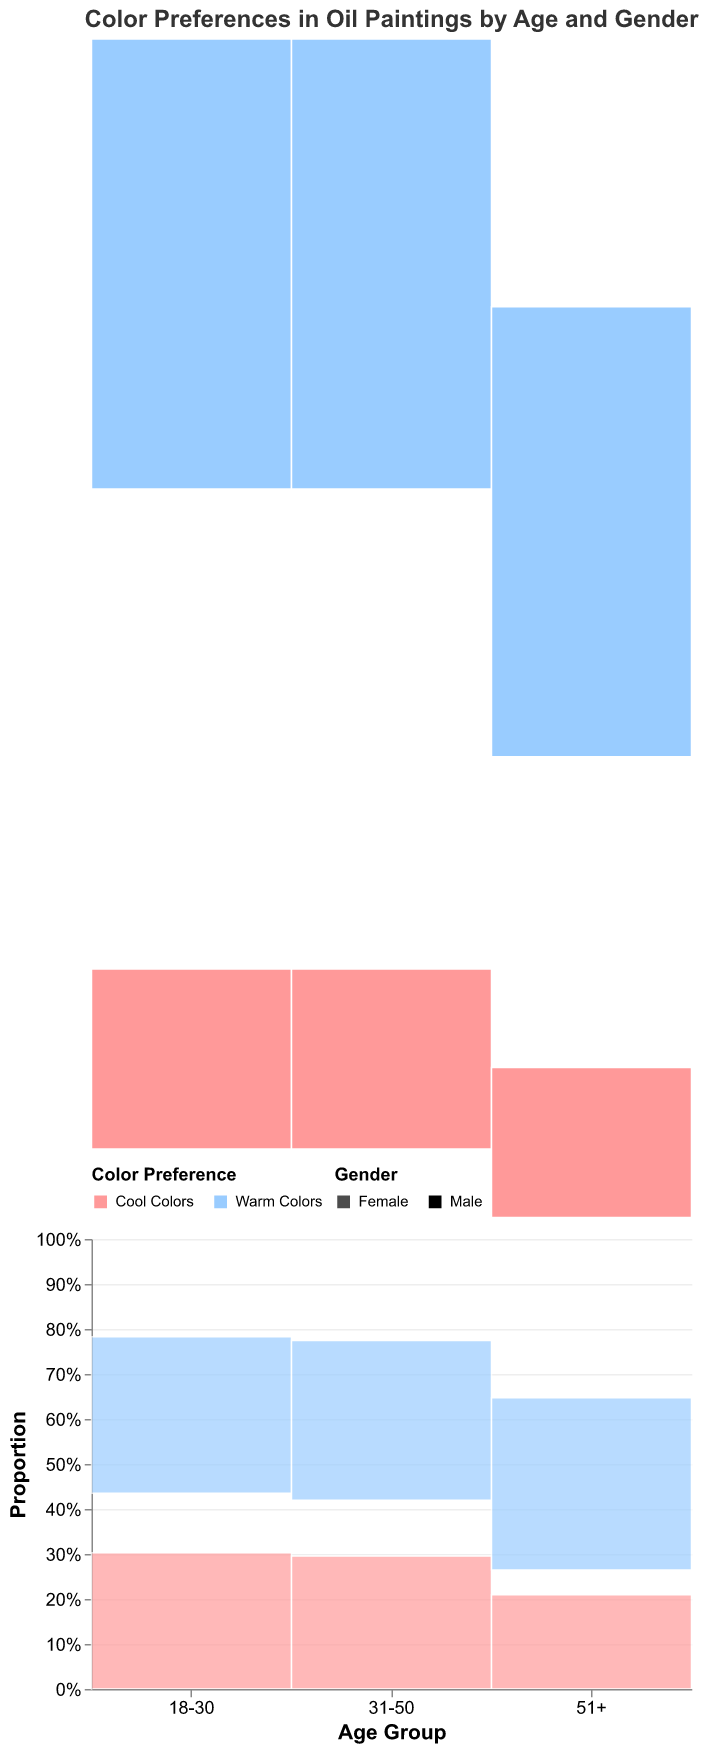What is the title of the figure? The title of a figure is usually displayed at the top and gives insight into what the figure represents. In this case, it provides an overview of the focus of the data visualization.
Answer: Color Preferences in Oil Paintings by Age and Gender Which age group has the highest preference for warm colors? By examining the sections representing each age group, we compare the proportions dedicated to warm colors. The 51+ group has the largest segment.
Answer: 51+ How does the color preference for cool colors differ between males and females aged 18-30? Comparing the sizes of the segments for males and females within the 18-30 age group for cool colors, we see that females have a larger proportion.
Answer: Females prefer cool colors more What is the sum of counts for warm colors across all age groups? Adding up the counts for warm colors from each age group for both genders: (45 + 40) + (60 + 55) + (70 + 65) = 335.
Answer: 335 Which gender shows a stronger preference for warm colors in the 31-50 age group? The segments for warm colors in the 31-50 age group can be compared. Males have a greater segment compared to females.
Answer: Males Are cool colors overall more preferred by females or males? By comparing the total segments for cool colors across all age groups for each gender, we can see that females have larger segments, indicating a stronger preference.
Answer: Females What is the proportion of warm color preference for males in the 51+ age group? The data for males in the 51+ age group shows 70 counts for warm colors out of a total sum for that category, which is 105 (70 warm + 35 cool). The proportion is 70/105.
Answer: 2/3 or approximately 67% What is the count difference in cool color preference between males and females in the 31-50 age group? The count for males is 40 and for females is 65. The difference is 65 - 40.
Answer: 25 How do the preferences for warm colors compare between the youngest and oldest age groups? By examining the segments for warm colors in both the youngest (18-30) and oldest (51+) age groups, it's clear that the preference increases with age, shown by larger segments in the oldest group.
Answer: Preference for warm colors increases with age What trend can be observed about the preference for warm colors as age increases? Observing the segments for warm colors across the age groups from 18-30, 31-50 to 51+, we notice an increasing trend in preference for warm colors with age.
Answer: Warm color preference increases with age 